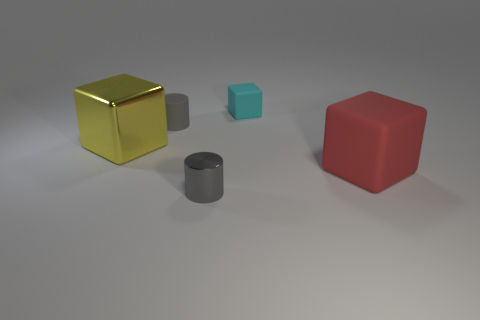Is the number of tiny rubber cylinders less than the number of cyan shiny objects?
Your response must be concise. No. How many other things are the same color as the tiny matte cylinder?
Your response must be concise. 1. How many shiny cylinders are there?
Offer a very short reply. 1. Is the number of tiny cyan blocks behind the small rubber block less than the number of brown rubber cubes?
Provide a short and direct response. No. Do the cylinder that is behind the big yellow shiny object and the big yellow block have the same material?
Your response must be concise. No. What shape is the thing on the left side of the small cylinder that is to the left of the small gray object that is in front of the yellow shiny block?
Offer a terse response. Cube. Is there a gray metallic object of the same size as the cyan thing?
Offer a very short reply. Yes. What is the size of the red cube?
Make the answer very short. Large. What number of red matte things have the same size as the gray rubber object?
Ensure brevity in your answer.  0. Are there fewer yellow objects that are behind the cyan object than red rubber blocks that are behind the big red cube?
Your answer should be compact. No. 